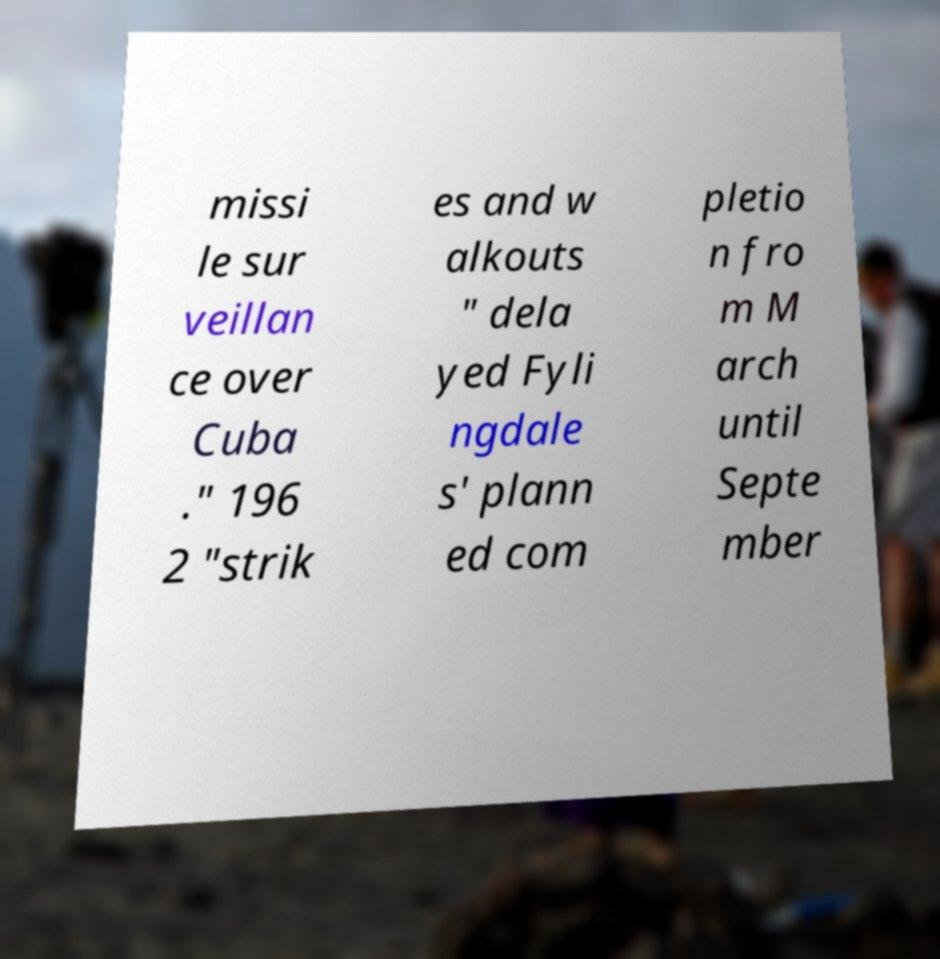There's text embedded in this image that I need extracted. Can you transcribe it verbatim? missi le sur veillan ce over Cuba ." 196 2 "strik es and w alkouts " dela yed Fyli ngdale s' plann ed com pletio n fro m M arch until Septe mber 